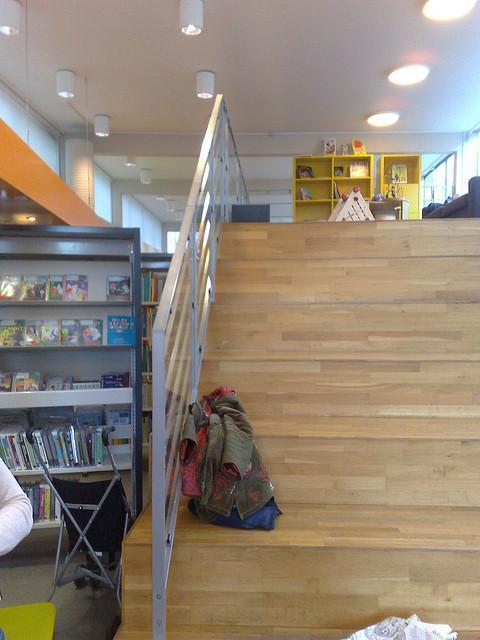How many bookshelves?
Give a very brief answer. 3. 